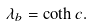<formula> <loc_0><loc_0><loc_500><loc_500>\lambda _ { b } = \coth c .</formula> 